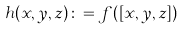<formula> <loc_0><loc_0><loc_500><loc_500>h ( x , y , z ) \colon = f ( [ x , y , z ] )</formula> 